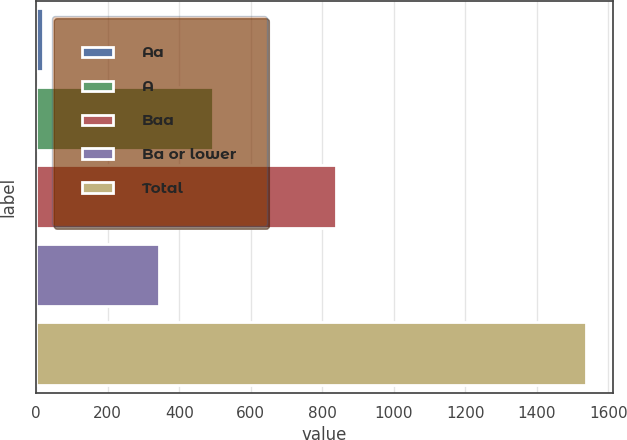Convert chart. <chart><loc_0><loc_0><loc_500><loc_500><bar_chart><fcel>Aa<fcel>A<fcel>Baa<fcel>Ba or lower<fcel>Total<nl><fcel>19<fcel>493.7<fcel>838<fcel>342<fcel>1536<nl></chart> 